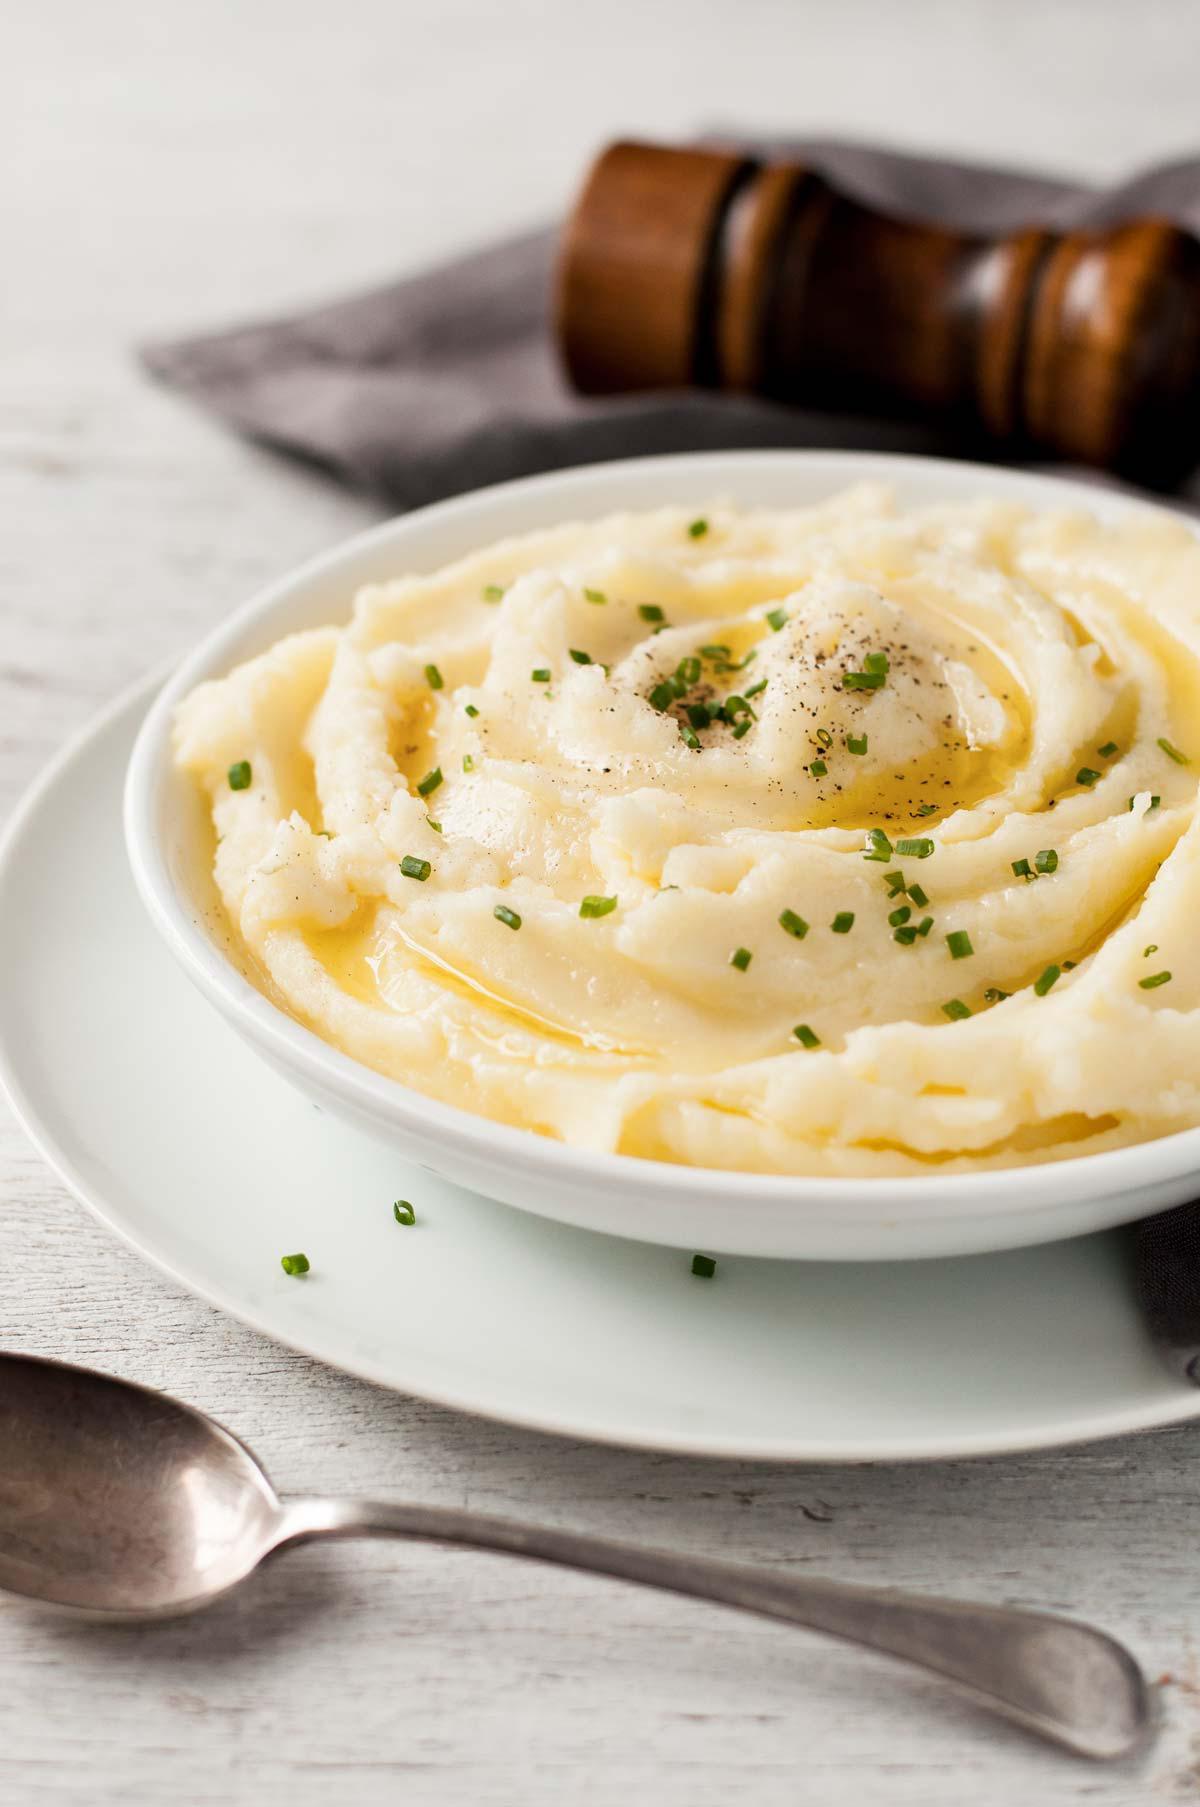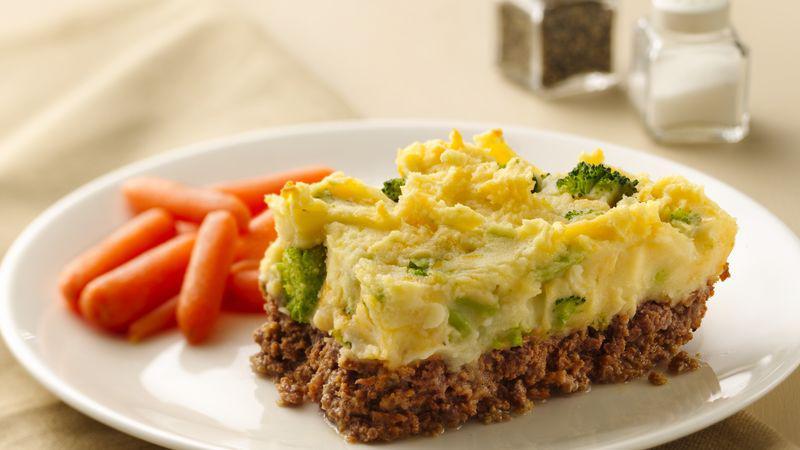The first image is the image on the left, the second image is the image on the right. Considering the images on both sides, is "The left image shows a white bowl of food with a utensil handle sticking out, and the right image includes a spoon that is not sticking out of the food." valid? Answer yes or no. No. The first image is the image on the left, the second image is the image on the right. For the images shown, is this caption "A silver spoon is set near the dish on the right." true? Answer yes or no. No. 